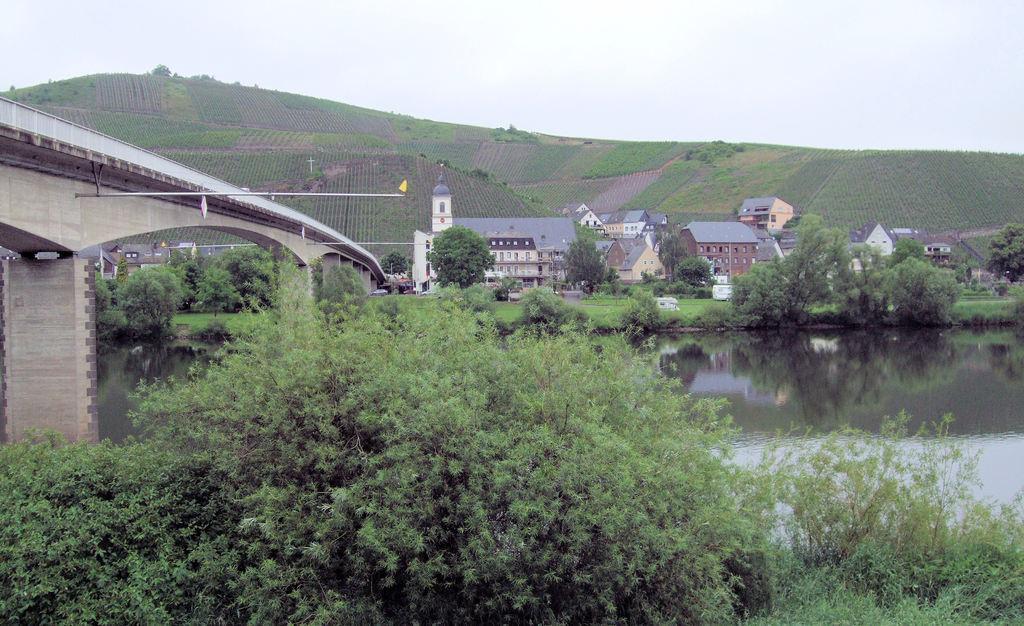Can you describe this image briefly? There are a lot of plants and trees,next to the trees there is a river and there is a bridge across the river,in the right side of the bridge there are many houses and in the background there are beautiful crops. 